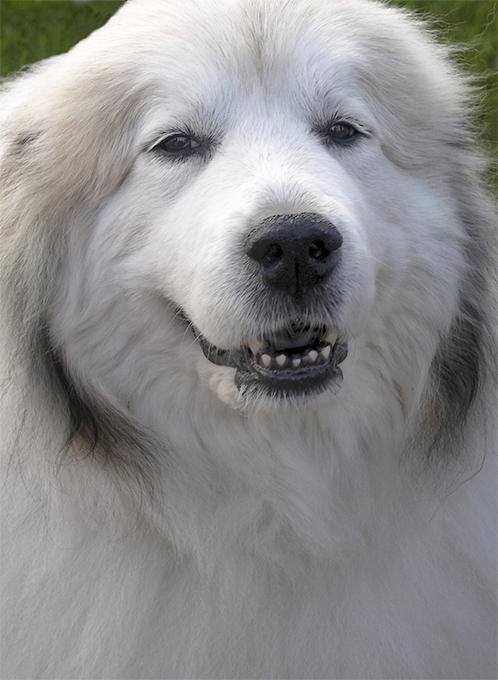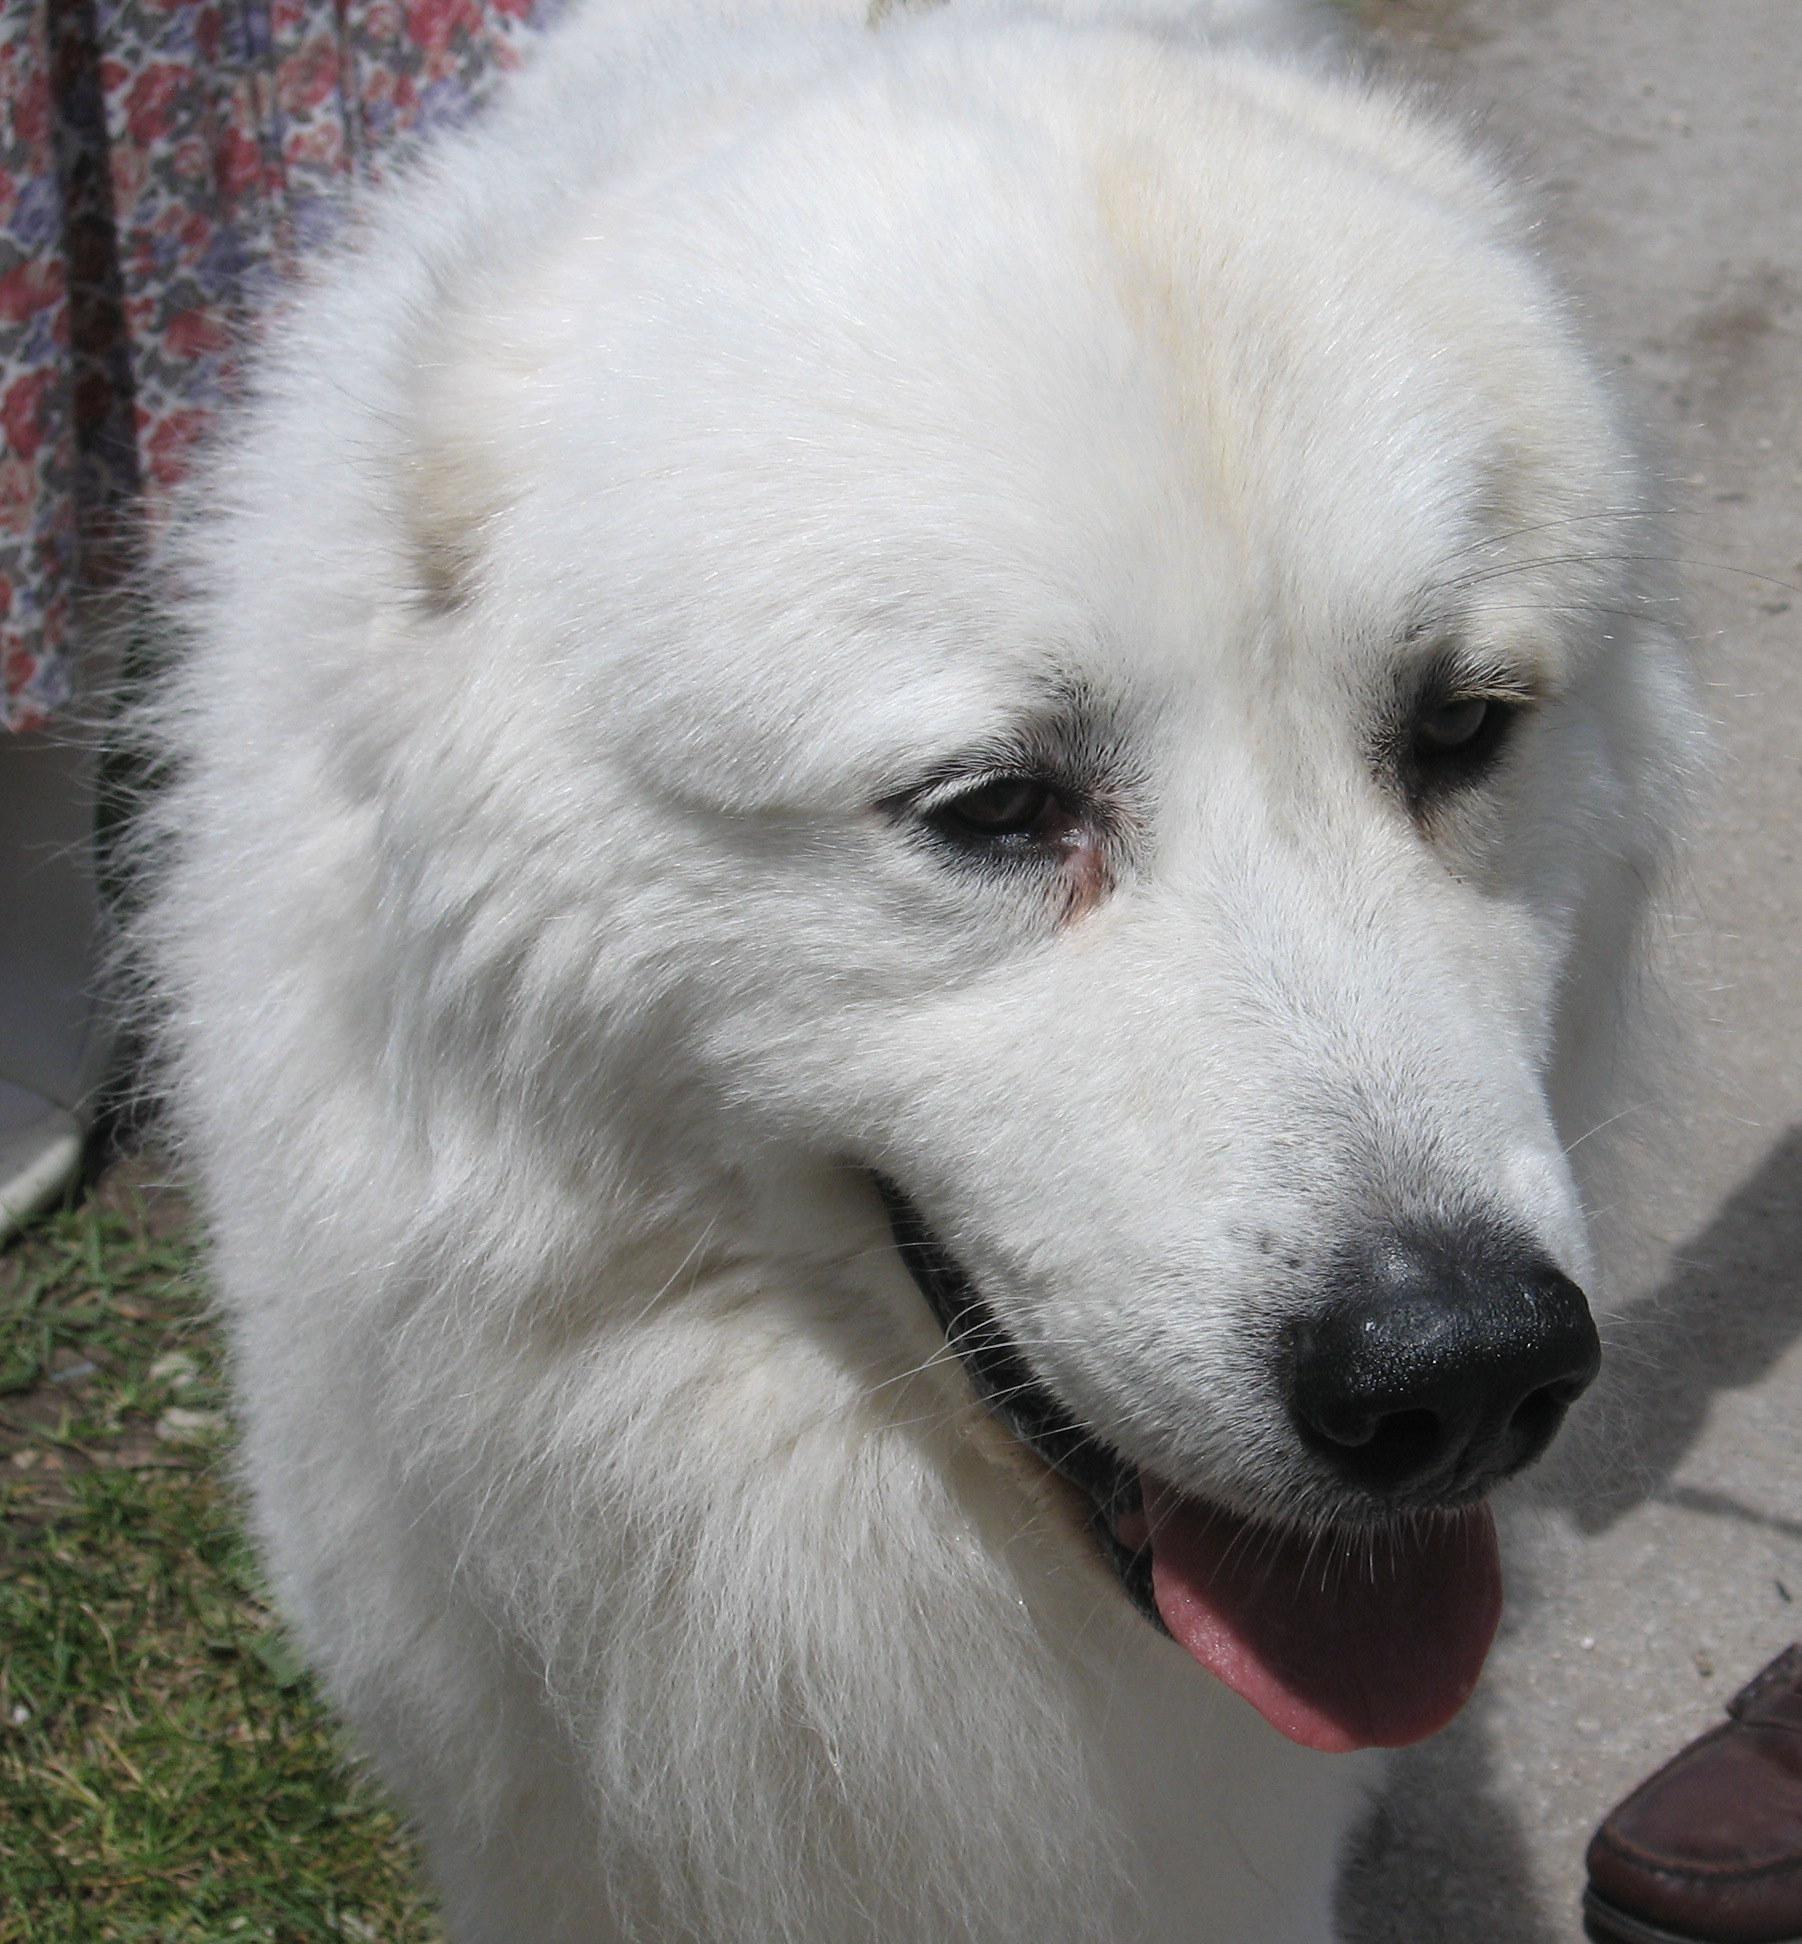The first image is the image on the left, the second image is the image on the right. Assess this claim about the two images: "The puppy on the left image is showing its tongue". Correct or not? Answer yes or no. No. 